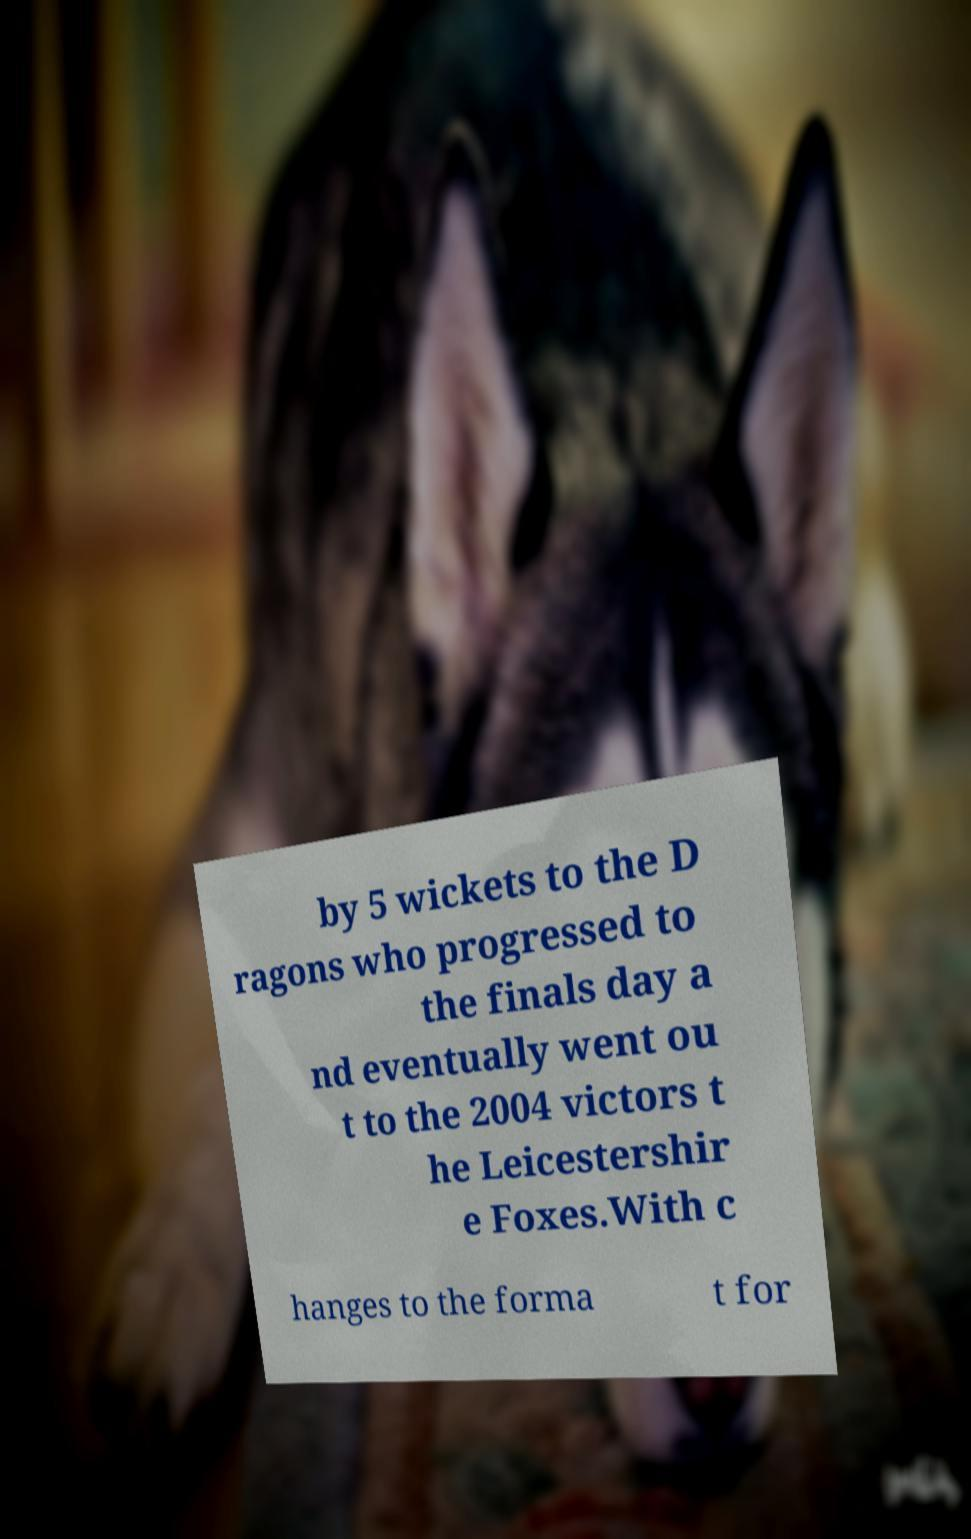Please identify and transcribe the text found in this image. by 5 wickets to the D ragons who progressed to the finals day a nd eventually went ou t to the 2004 victors t he Leicestershir e Foxes.With c hanges to the forma t for 